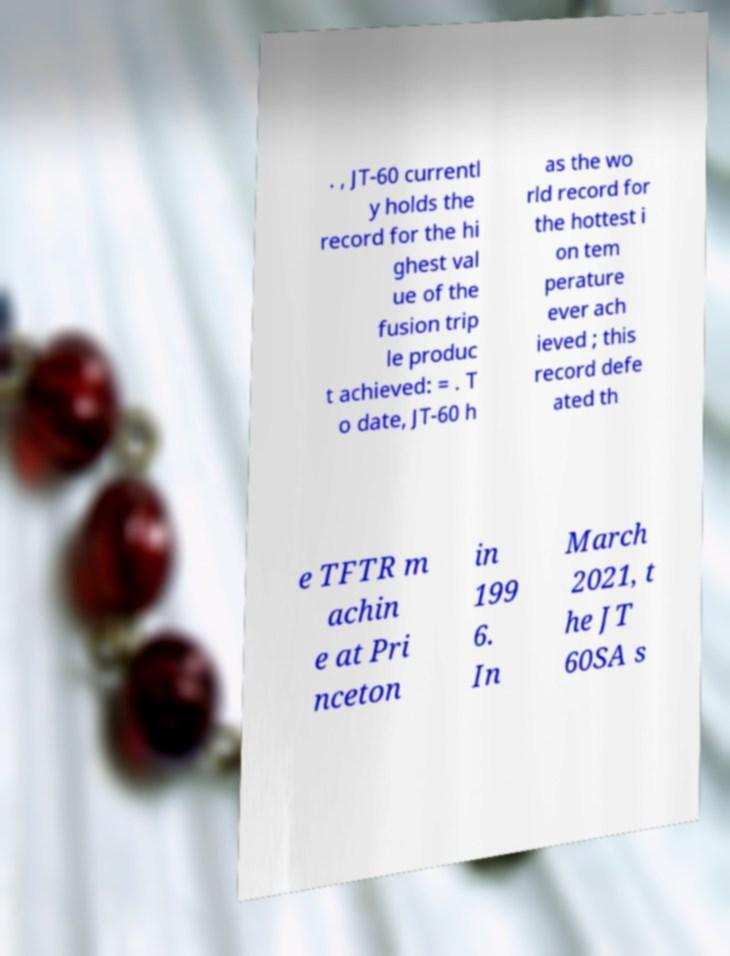Please identify and transcribe the text found in this image. . , JT-60 currentl y holds the record for the hi ghest val ue of the fusion trip le produc t achieved: = . T o date, JT-60 h as the wo rld record for the hottest i on tem perature ever ach ieved ; this record defe ated th e TFTR m achin e at Pri nceton in 199 6. In March 2021, t he JT 60SA s 